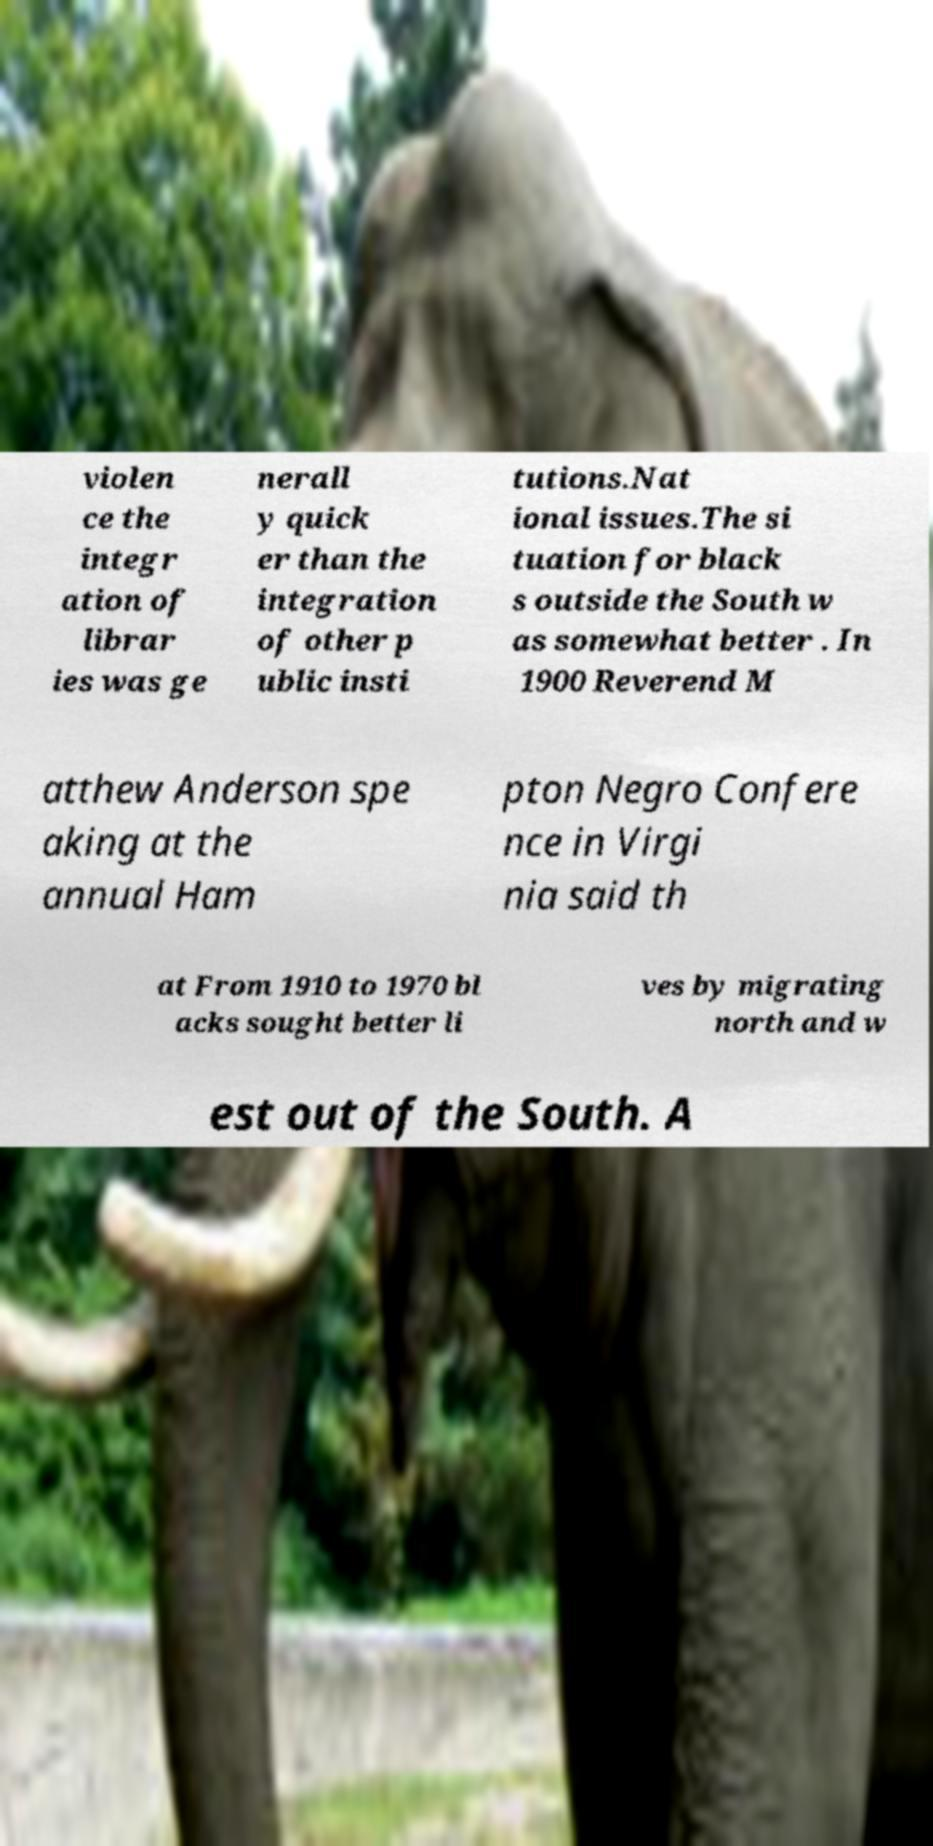Could you assist in decoding the text presented in this image and type it out clearly? violen ce the integr ation of librar ies was ge nerall y quick er than the integration of other p ublic insti tutions.Nat ional issues.The si tuation for black s outside the South w as somewhat better . In 1900 Reverend M atthew Anderson spe aking at the annual Ham pton Negro Confere nce in Virgi nia said th at From 1910 to 1970 bl acks sought better li ves by migrating north and w est out of the South. A 